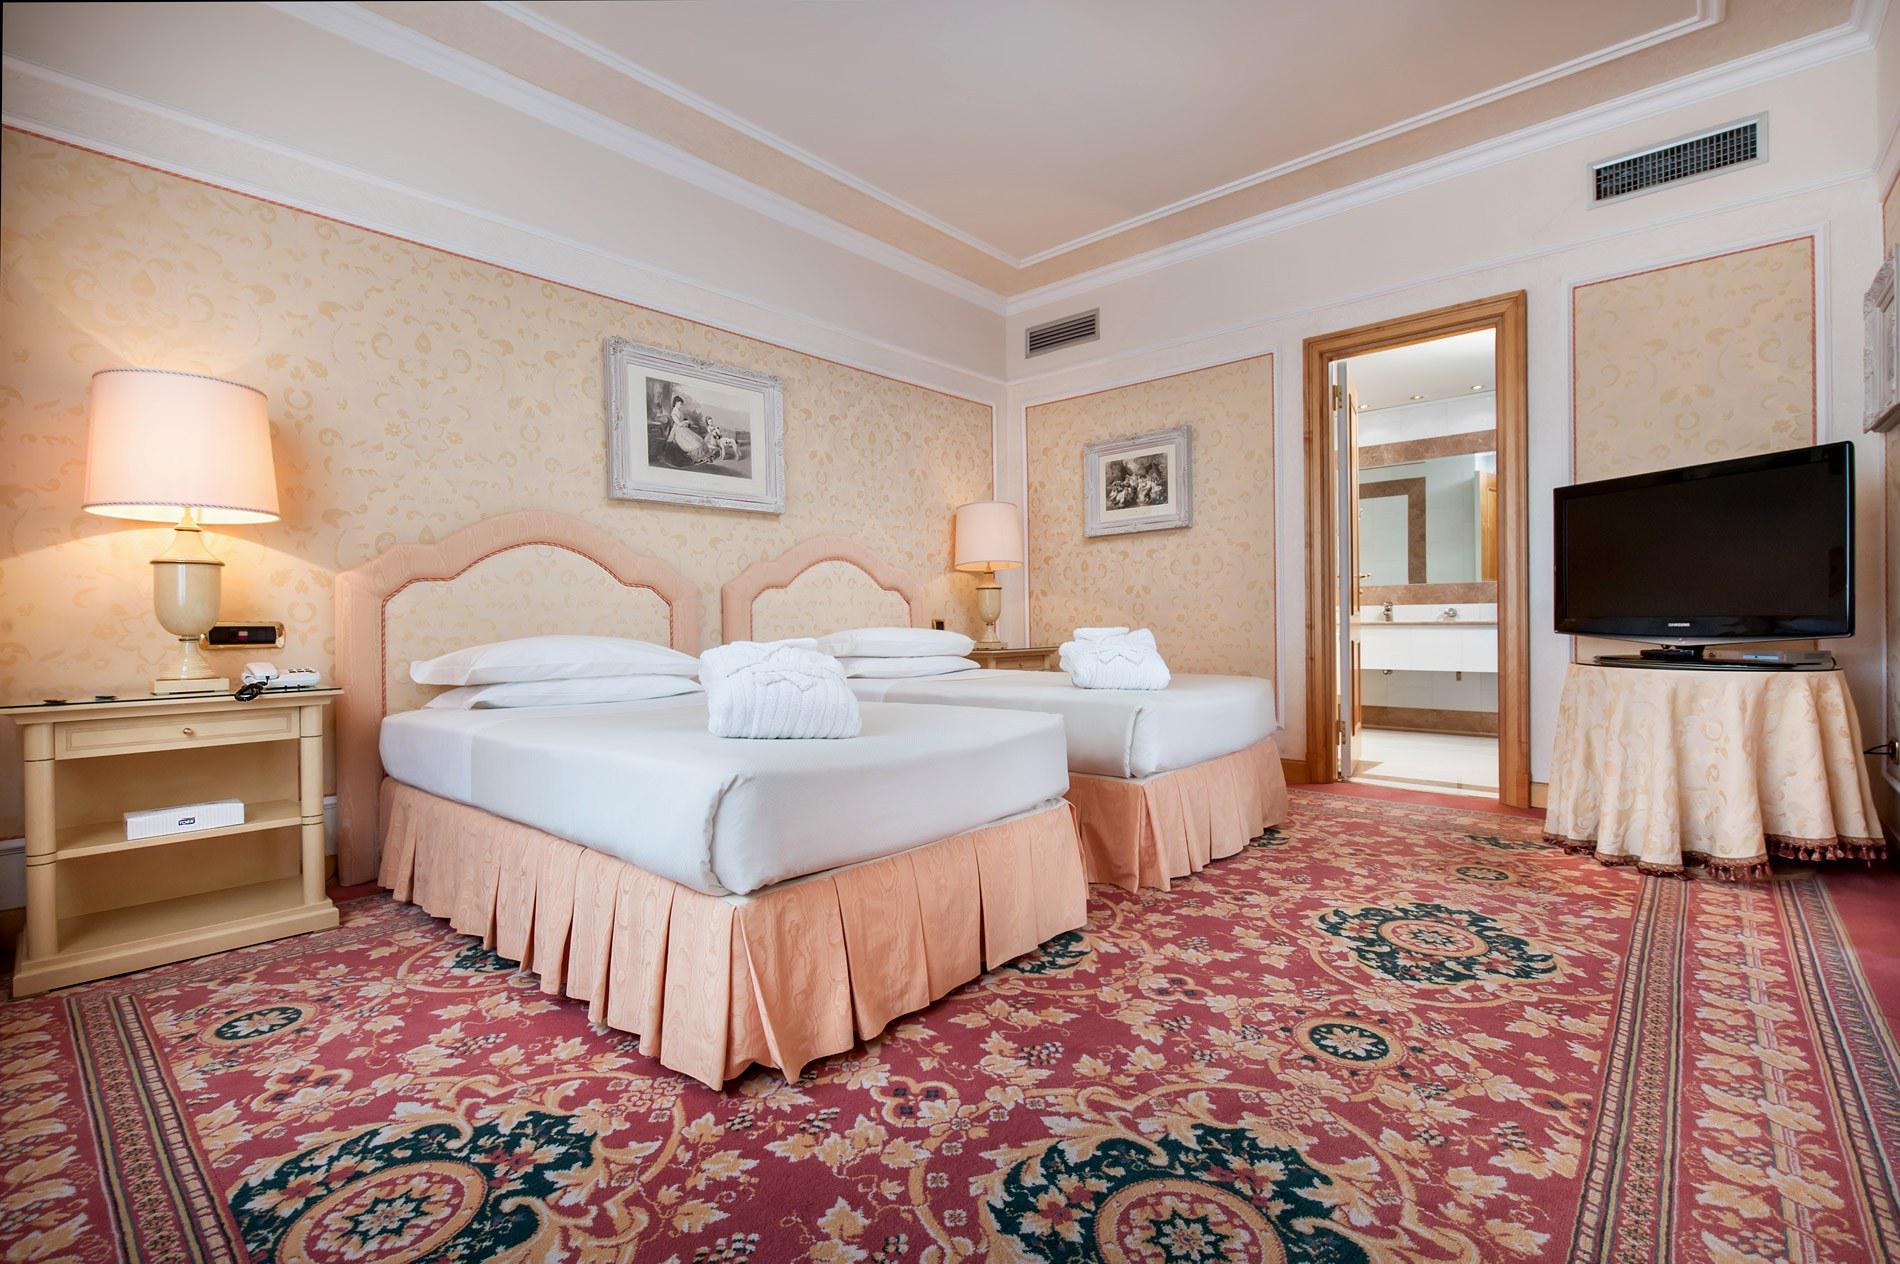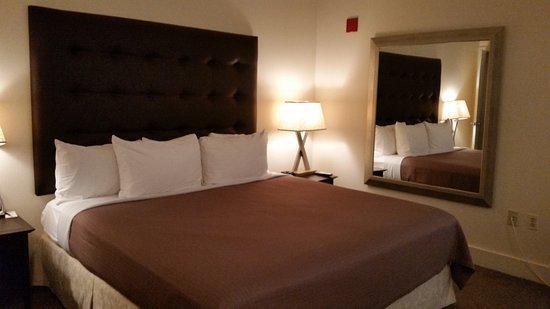The first image is the image on the left, the second image is the image on the right. Given the left and right images, does the statement "There are no less than three beds" hold true? Answer yes or no. Yes. 